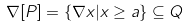<formula> <loc_0><loc_0><loc_500><loc_500>\nabla [ P ] = \{ \nabla x | x \geq a \} \subseteq Q</formula> 